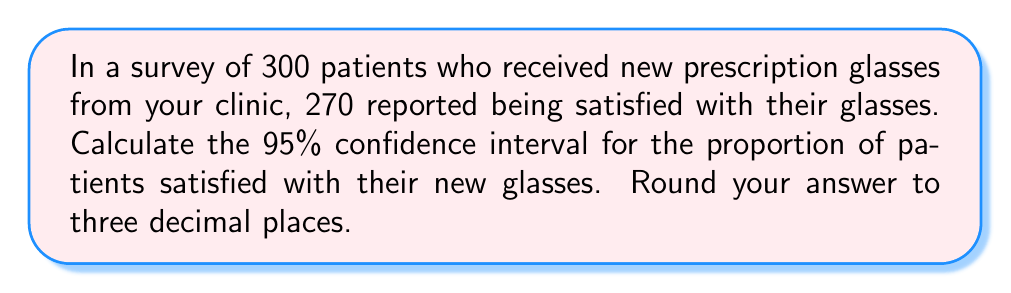Could you help me with this problem? Let's approach this step-by-step:

1) First, we need to calculate the sample proportion:
   $\hat{p} = \frac{\text{number of successes}}{\text{sample size}} = \frac{270}{300} = 0.9$

2) The formula for the confidence interval of a proportion is:
   $$\hat{p} \pm z_{\alpha/2} \sqrt{\frac{\hat{p}(1-\hat{p})}{n}}$$

   Where:
   - $\hat{p}$ is the sample proportion
   - $z_{\alpha/2}$ is the critical value (for 95% CI, this is 1.96)
   - $n$ is the sample size

3) Let's plug in our values:
   $$0.9 \pm 1.96 \sqrt{\frac{0.9(1-0.9)}{300}}$$

4) Simplify inside the square root:
   $$0.9 \pm 1.96 \sqrt{\frac{0.9(0.1)}{300}} = 0.9 \pm 1.96 \sqrt{\frac{0.09}{300}}$$

5) Calculate:
   $$0.9 \pm 1.96 \sqrt{0.0003} = 0.9 \pm 1.96(0.0173) = 0.9 \pm 0.0339$$

6) Therefore, the confidence interval is:
   $$(0.9 - 0.0339, 0.9 + 0.0339) = (0.8661, 0.9339)$$

7) Rounding to three decimal places:
   $$(0.866, 0.934)$$
Answer: (0.866, 0.934) 